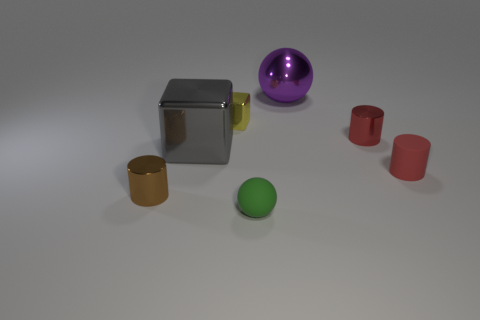Can you describe the material differences between the objects in the image? Certainly, the objects display a variety of materials. The silver cube in the center has a metallic finish that suggests it's made of metal, reflecting light sharply. The purple sphere has a glossy finish that could be plastic or glass, due to its reflective surface. The small green sphere has a matte finish, indicating a more rubbery texture. Lastly, the red and gold cylinders have a less reflective, more plastic-like appearance. 